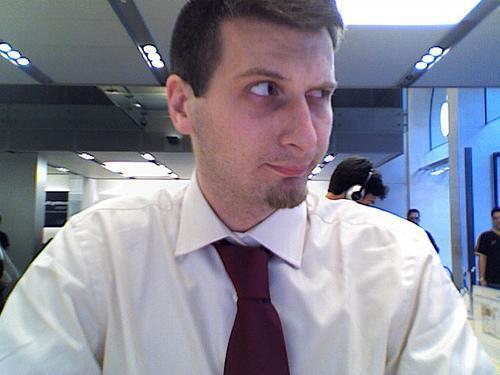How many ties can you see?
Give a very brief answer. 1. 